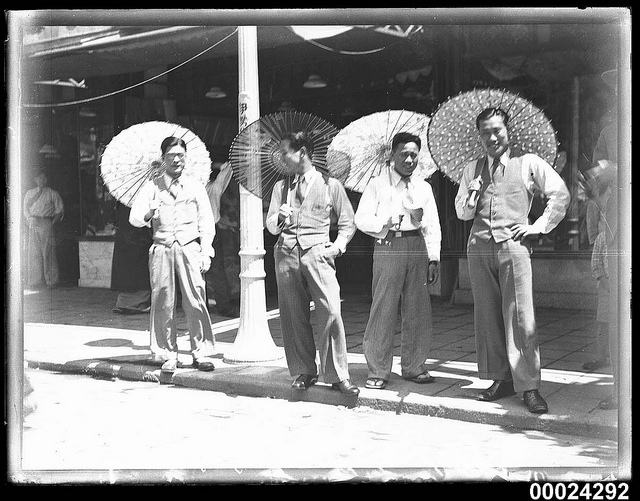Please transcribe the text in this image. 00024292 